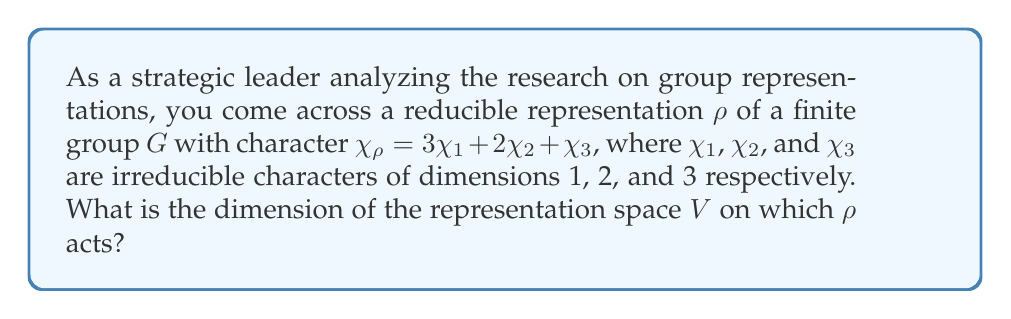Give your solution to this math problem. To find the dimension of the representation space $V$, we need to follow these steps:

1) Recall that the character of a representation evaluated at the identity element gives the dimension of the representation space:
   $$\dim(V) = \chi_\rho(e)$$

2) The given character $\chi_\rho$ is a linear combination of irreducible characters:
   $$\chi_\rho = 3\chi_1 + 2\chi_2 + \chi_3$$

3) Evaluate this at the identity element $e$:
   $$\chi_\rho(e) = 3\chi_1(e) + 2\chi_2(e) + \chi_3(e)$$

4) We're given that $\chi_1$, $\chi_2$, and $\chi_3$ have dimensions 1, 2, and 3 respectively. This means:
   $$\chi_1(e) = 1, \chi_2(e) = 2, \chi_3(e) = 3$$

5) Substituting these values:
   $$\chi_\rho(e) = 3(1) + 2(2) + 1(3) = 3 + 4 + 3 = 10$$

6) Therefore, the dimension of the representation space $V$ is:
   $$\dim(V) = \chi_\rho(e) = 10$$
Answer: 10 